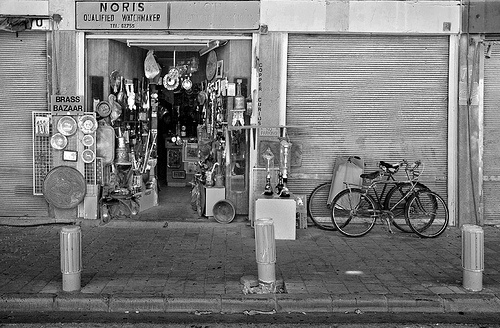Describe the objects in this image and their specific colors. I can see bicycle in lightgray, gray, black, and darkgray tones, bicycle in lightgray, gray, black, and darkgray tones, and bowl in gray, black, and lightgray tones in this image. 